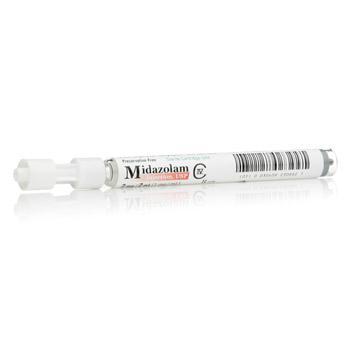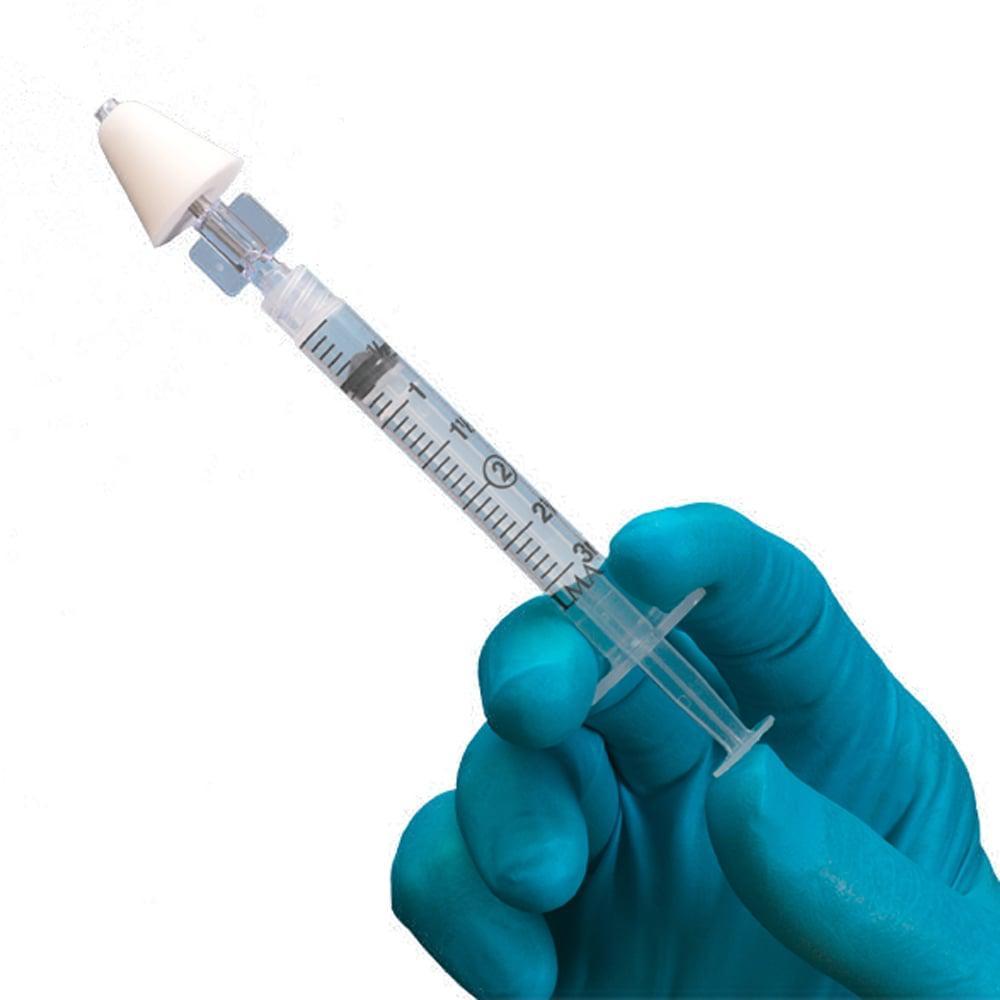The first image is the image on the left, the second image is the image on the right. Examine the images to the left and right. Is the description "There is at least one gloved hand in the picture." accurate? Answer yes or no. Yes. 